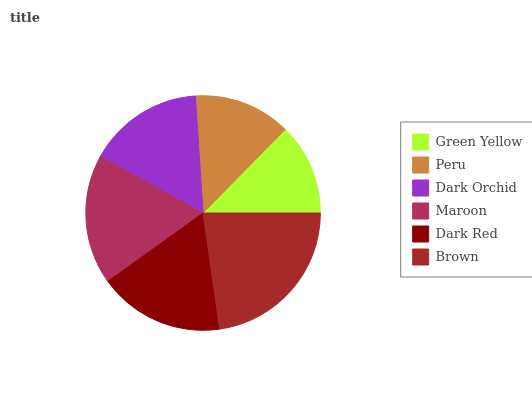Is Green Yellow the minimum?
Answer yes or no. Yes. Is Brown the maximum?
Answer yes or no. Yes. Is Peru the minimum?
Answer yes or no. No. Is Peru the maximum?
Answer yes or no. No. Is Peru greater than Green Yellow?
Answer yes or no. Yes. Is Green Yellow less than Peru?
Answer yes or no. Yes. Is Green Yellow greater than Peru?
Answer yes or no. No. Is Peru less than Green Yellow?
Answer yes or no. No. Is Dark Red the high median?
Answer yes or no. Yes. Is Dark Orchid the low median?
Answer yes or no. Yes. Is Maroon the high median?
Answer yes or no. No. Is Maroon the low median?
Answer yes or no. No. 